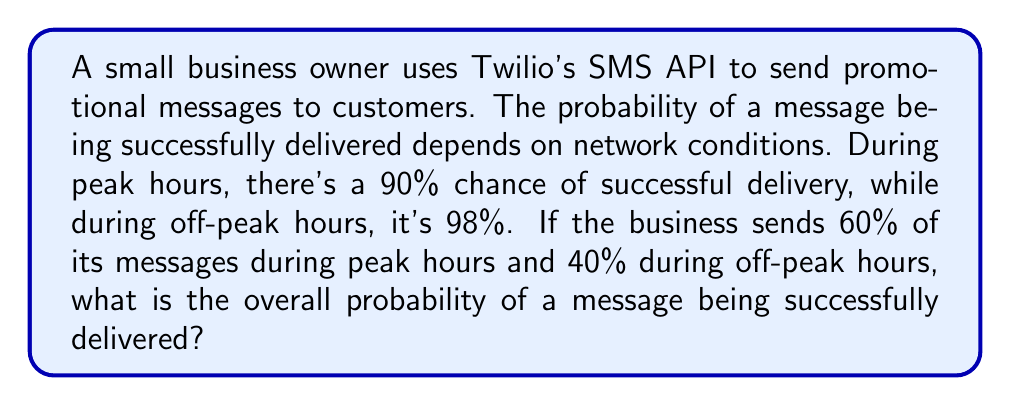Teach me how to tackle this problem. Let's approach this step-by-step using the law of total probability:

1) Let's define our events:
   A = message is successfully delivered
   P = message is sent during peak hours
   O = message is sent during off-peak hours

2) We're given:
   $P(A|P) = 0.90$ (probability of successful delivery during peak hours)
   $P(A|O) = 0.98$ (probability of successful delivery during off-peak hours)
   $P(P) = 0.60$ (probability of sending during peak hours)
   $P(O) = 0.40$ (probability of sending during off-peak hours)

3) The law of total probability states:
   $$P(A) = P(A|P) \cdot P(P) + P(A|O) \cdot P(O)$$

4) Let's substitute our values:
   $$P(A) = 0.90 \cdot 0.60 + 0.98 \cdot 0.40$$

5) Now let's calculate:
   $$P(A) = 0.54 + 0.392 = 0.932$$

Therefore, the overall probability of a message being successfully delivered is 0.932 or 93.2%.
Answer: 0.932 or 93.2% 